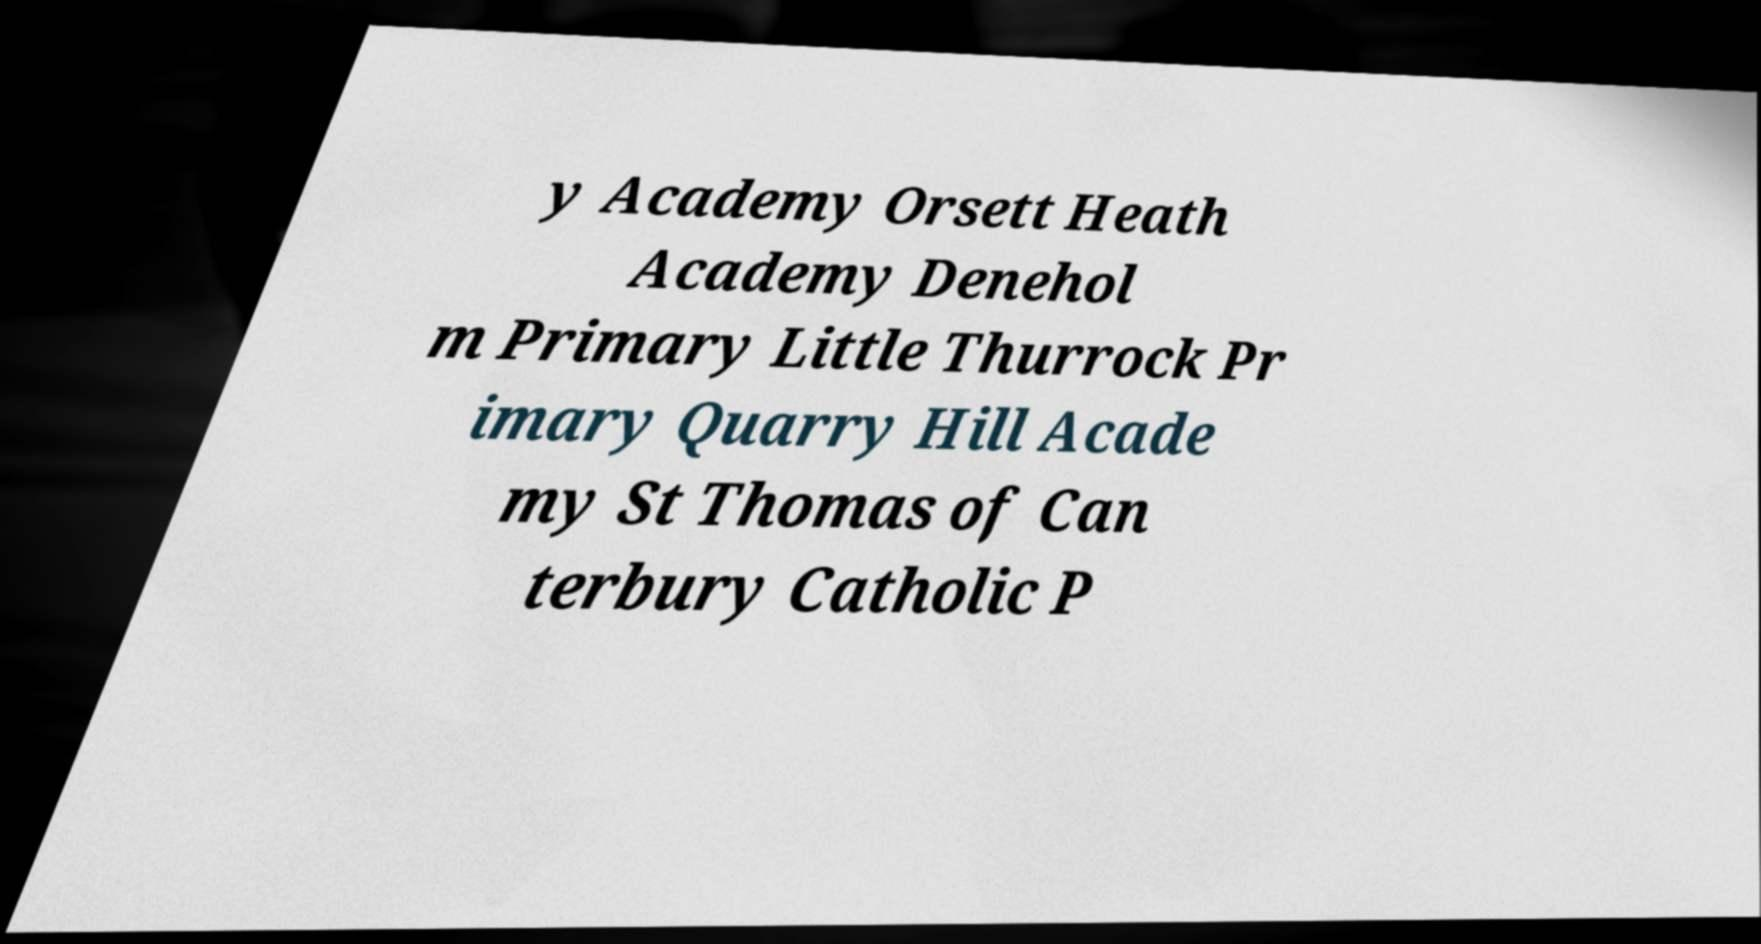I need the written content from this picture converted into text. Can you do that? y Academy Orsett Heath Academy Denehol m Primary Little Thurrock Pr imary Quarry Hill Acade my St Thomas of Can terbury Catholic P 